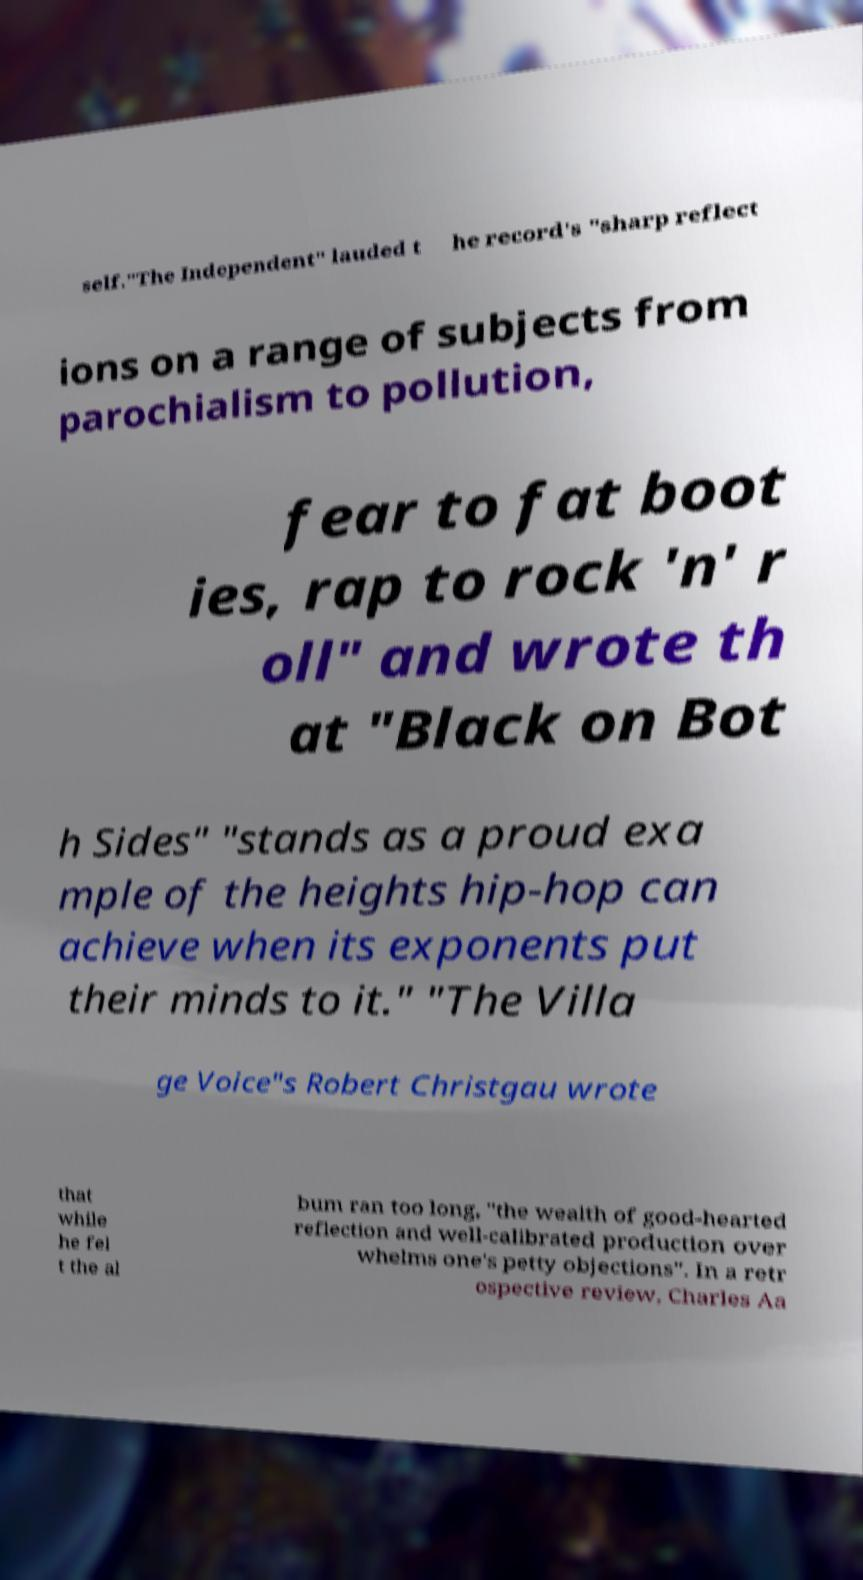There's text embedded in this image that I need extracted. Can you transcribe it verbatim? self."The Independent" lauded t he record's "sharp reflect ions on a range of subjects from parochialism to pollution, fear to fat boot ies, rap to rock 'n' r oll" and wrote th at "Black on Bot h Sides" "stands as a proud exa mple of the heights hip-hop can achieve when its exponents put their minds to it." "The Villa ge Voice"s Robert Christgau wrote that while he fel t the al bum ran too long, "the wealth of good-hearted reflection and well-calibrated production over whelms one's petty objections". In a retr ospective review, Charles Aa 